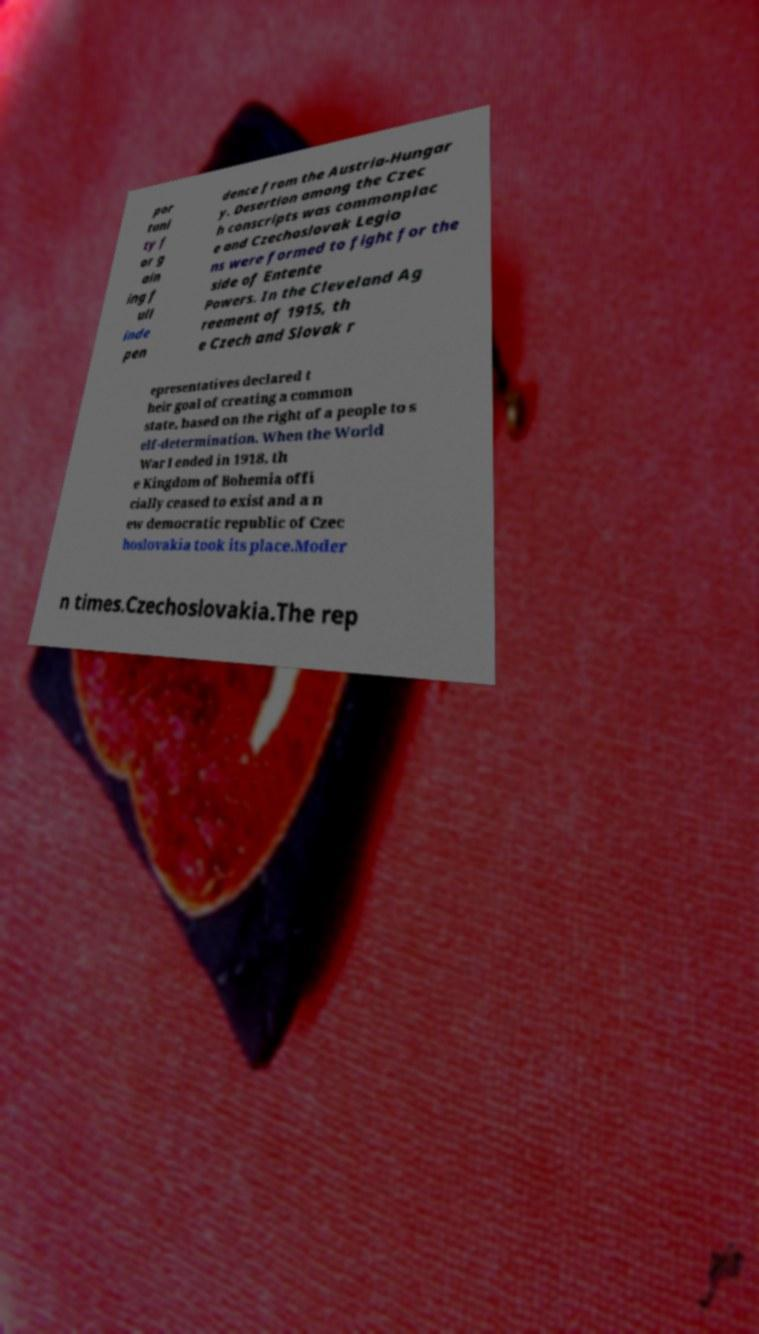Could you assist in decoding the text presented in this image and type it out clearly? por tuni ty f or g ain ing f ull inde pen dence from the Austria-Hungar y. Desertion among the Czec h conscripts was commonplac e and Czechoslovak Legio ns were formed to fight for the side of Entente Powers. In the Cleveland Ag reement of 1915, th e Czech and Slovak r epresentatives declared t heir goal of creating a common state, based on the right of a people to s elf-determination. When the World War I ended in 1918, th e Kingdom of Bohemia offi cially ceased to exist and a n ew democratic republic of Czec hoslovakia took its place.Moder n times.Czechoslovakia.The rep 